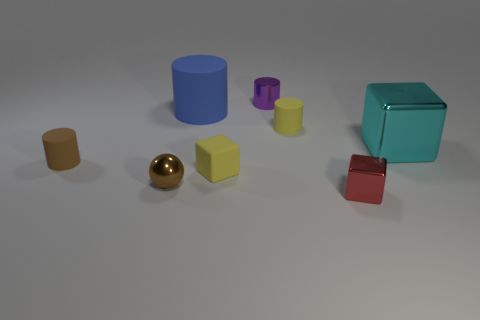Subtract all matte cylinders. How many cylinders are left? 1 Subtract 1 blocks. How many blocks are left? 2 Add 2 large metal objects. How many objects exist? 10 Subtract all brown cylinders. How many cylinders are left? 3 Subtract all blocks. How many objects are left? 5 Subtract 1 brown balls. How many objects are left? 7 Subtract all blue blocks. Subtract all purple spheres. How many blocks are left? 3 Subtract all large blue rubber cylinders. Subtract all big rubber things. How many objects are left? 6 Add 2 yellow things. How many yellow things are left? 4 Add 1 purple shiny objects. How many purple shiny objects exist? 2 